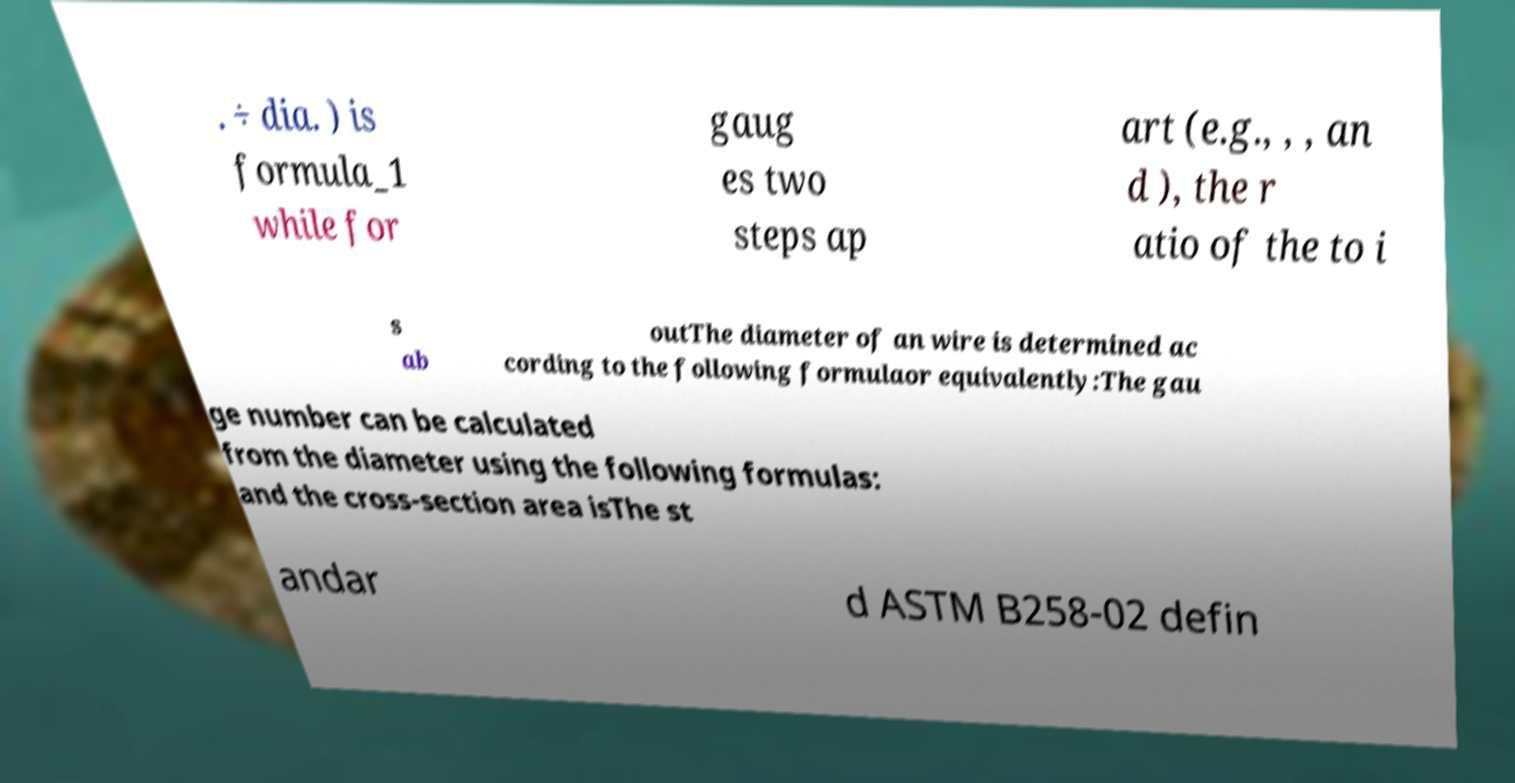There's text embedded in this image that I need extracted. Can you transcribe it verbatim? . ÷ dia. ) is formula_1 while for gaug es two steps ap art (e.g., , , an d ), the r atio of the to i s ab outThe diameter of an wire is determined ac cording to the following formulaor equivalently:The gau ge number can be calculated from the diameter using the following formulas: and the cross-section area isThe st andar d ASTM B258-02 defin 